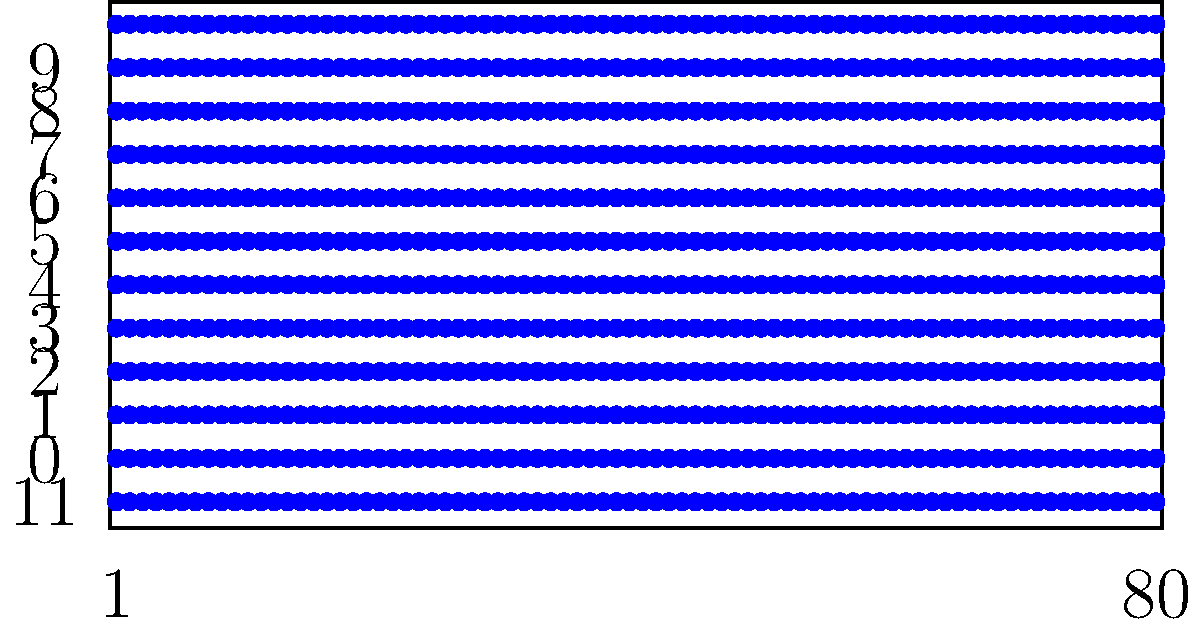In early computer networks, punch cards were used for data input and storage. The image shows a typical 80-column punch card layout. How many rows are available for punching holes on this card, and what was the significance of the top row (often labeled as row 12)? To answer this question, let's analyze the punch card layout:

1. Count the rows: The punch card has 12 rows for punching holes.

2. Row numbering: The rows are typically numbered from bottom to top as 0, 1, 2, 3, 4, 5, 6, 7, 8, 9, 11, and 12 (or sometimes Y and X for the top two rows).

3. Significance of the top row (row 12):
   a. The top row was often used for special purposes or as a control row.
   b. In IBM punch cards, it was called the "Y" row or the "12" row.
   c. This row was used for:
      - Indicating negative numbers in numerical data
      - Representing special characters or symbols
      - Serving as a field delimiter or card type indicator

4. Data representation: The combination of punched holes in different rows allowed for representing various characters, numbers, and symbols.

5. Historical context: This 12-row, 80-column format became a standard in early computing and data processing, influencing subsequent computer designs and programming practices.
Answer: 12 rows; top row for special purposes (e.g., negative numbers, special characters) 